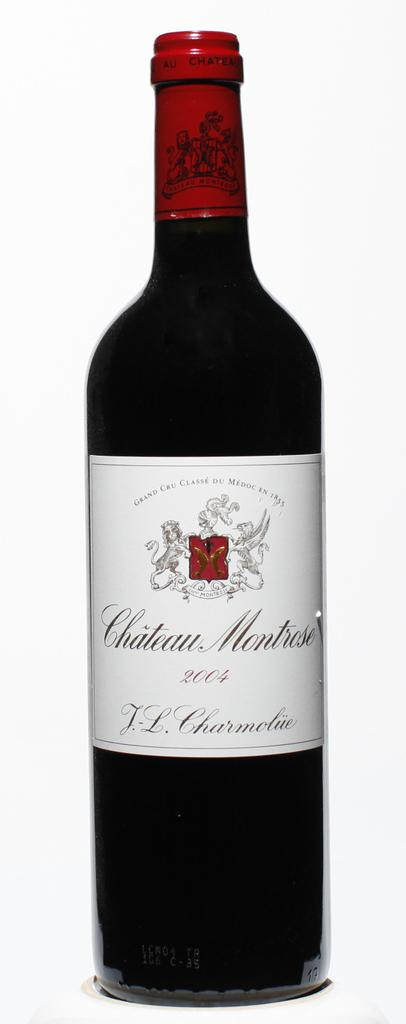What is the main object in the center of the image? There is a wine bottle in the center of the image. Can you describe the position of the wine bottle in the image? The wine bottle is in the center of the image. What type of hook can be seen attached to the wine bottle in the image? There is no hook attached to the wine bottle in the image. 